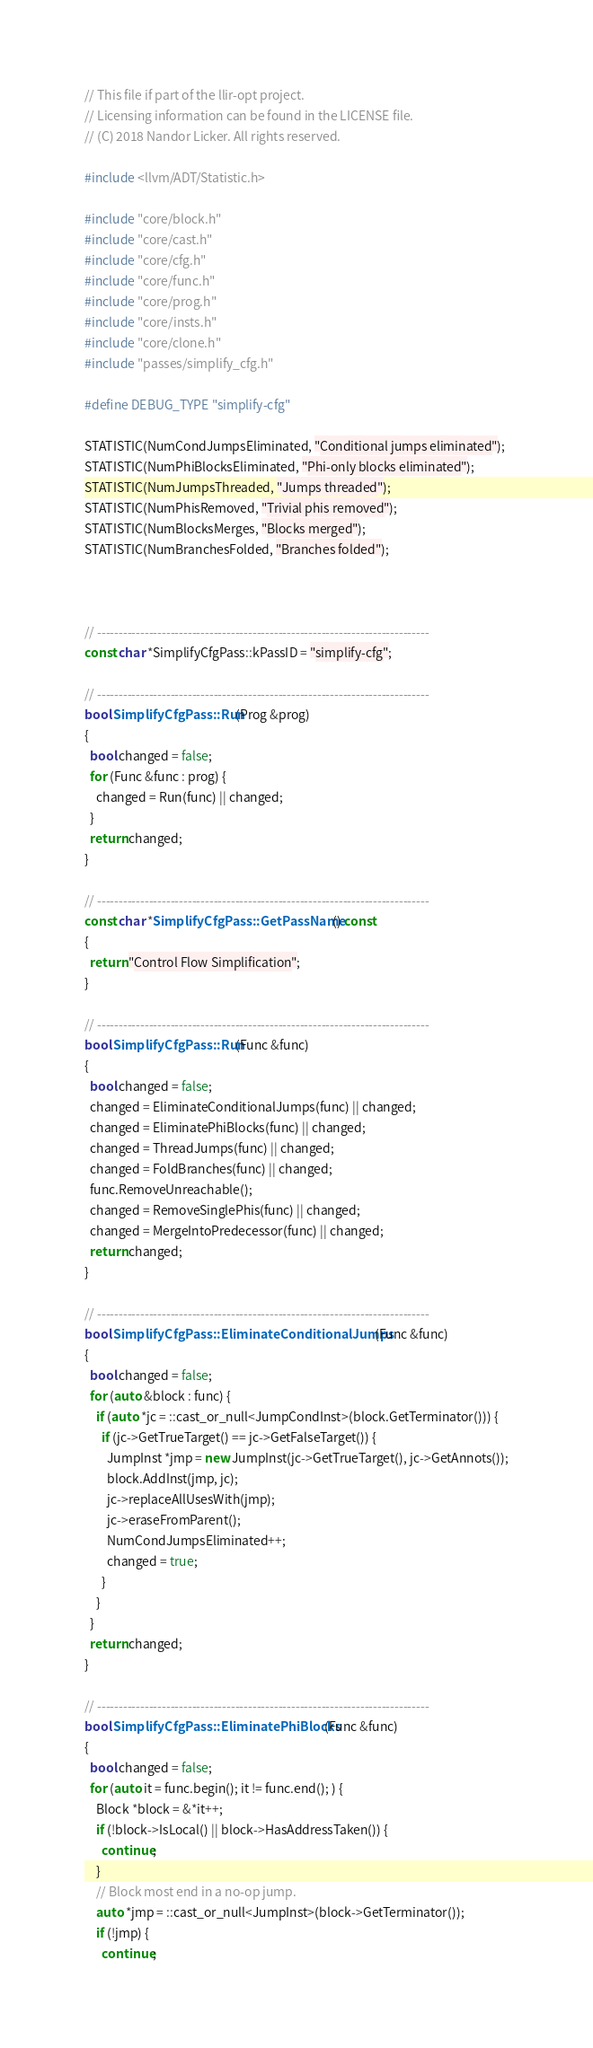<code> <loc_0><loc_0><loc_500><loc_500><_C++_>// This file if part of the llir-opt project.
// Licensing information can be found in the LICENSE file.
// (C) 2018 Nandor Licker. All rights reserved.

#include <llvm/ADT/Statistic.h>

#include "core/block.h"
#include "core/cast.h"
#include "core/cfg.h"
#include "core/func.h"
#include "core/prog.h"
#include "core/insts.h"
#include "core/clone.h"
#include "passes/simplify_cfg.h"

#define DEBUG_TYPE "simplify-cfg"

STATISTIC(NumCondJumpsEliminated, "Conditional jumps eliminated");
STATISTIC(NumPhiBlocksEliminated, "Phi-only blocks eliminated");
STATISTIC(NumJumpsThreaded, "Jumps threaded");
STATISTIC(NumPhisRemoved, "Trivial phis removed");
STATISTIC(NumBlocksMerges, "Blocks merged");
STATISTIC(NumBranchesFolded, "Branches folded");



// -----------------------------------------------------------------------------
const char *SimplifyCfgPass::kPassID = "simplify-cfg";

// -----------------------------------------------------------------------------
bool SimplifyCfgPass::Run(Prog &prog)
{
  bool changed = false;
  for (Func &func : prog) {
    changed = Run(func) || changed;
  }
  return changed;
}

// -----------------------------------------------------------------------------
const char *SimplifyCfgPass::GetPassName() const
{
  return "Control Flow Simplification";
}

// -----------------------------------------------------------------------------
bool SimplifyCfgPass::Run(Func &func)
{
  bool changed = false;
  changed = EliminateConditionalJumps(func) || changed;
  changed = EliminatePhiBlocks(func) || changed;
  changed = ThreadJumps(func) || changed;
  changed = FoldBranches(func) || changed;
  func.RemoveUnreachable();
  changed = RemoveSinglePhis(func) || changed;
  changed = MergeIntoPredecessor(func) || changed;
  return changed;
}

// -----------------------------------------------------------------------------
bool SimplifyCfgPass::EliminateConditionalJumps(Func &func)
{
  bool changed = false;
  for (auto &block : func) {
    if (auto *jc = ::cast_or_null<JumpCondInst>(block.GetTerminator())) {
      if (jc->GetTrueTarget() == jc->GetFalseTarget()) {
        JumpInst *jmp = new JumpInst(jc->GetTrueTarget(), jc->GetAnnots());
        block.AddInst(jmp, jc);
        jc->replaceAllUsesWith(jmp);
        jc->eraseFromParent();
        NumCondJumpsEliminated++;
        changed = true;
      }
    }
  }
  return changed;
}

// -----------------------------------------------------------------------------
bool SimplifyCfgPass::EliminatePhiBlocks(Func &func)
{
  bool changed = false;
  for (auto it = func.begin(); it != func.end(); ) {
    Block *block = &*it++;
    if (!block->IsLocal() || block->HasAddressTaken()) {
      continue;
    }
    // Block most end in a no-op jump.
    auto *jmp = ::cast_or_null<JumpInst>(block->GetTerminator());
    if (!jmp) {
      continue;</code> 